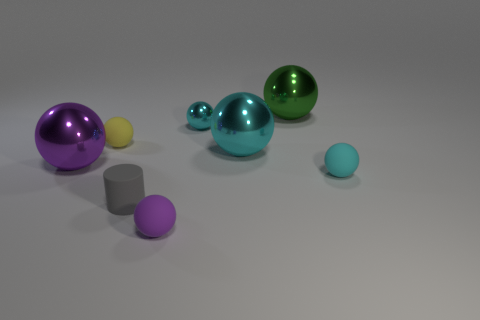What is the texture of the objects in the image? The objects in the image appear to have a smooth, reflective surface, indicating they might be made of materials like plastic or polished metal. Their glossy textures suggest they might feel quite slick to the touch. 